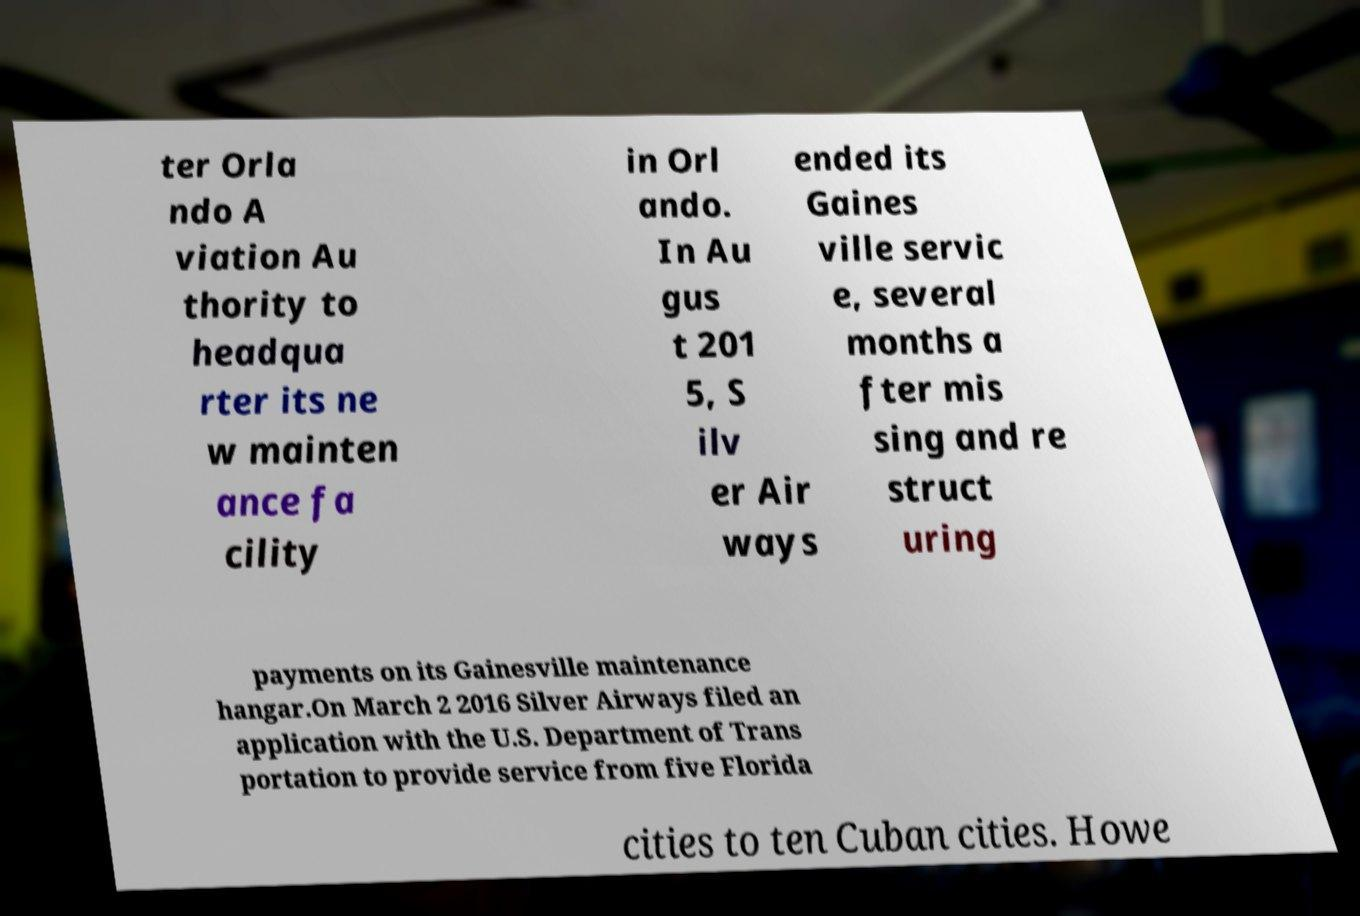Can you read and provide the text displayed in the image?This photo seems to have some interesting text. Can you extract and type it out for me? ter Orla ndo A viation Au thority to headqua rter its ne w mainten ance fa cility in Orl ando. In Au gus t 201 5, S ilv er Air ways ended its Gaines ville servic e, several months a fter mis sing and re struct uring payments on its Gainesville maintenance hangar.On March 2 2016 Silver Airways filed an application with the U.S. Department of Trans portation to provide service from five Florida cities to ten Cuban cities. Howe 